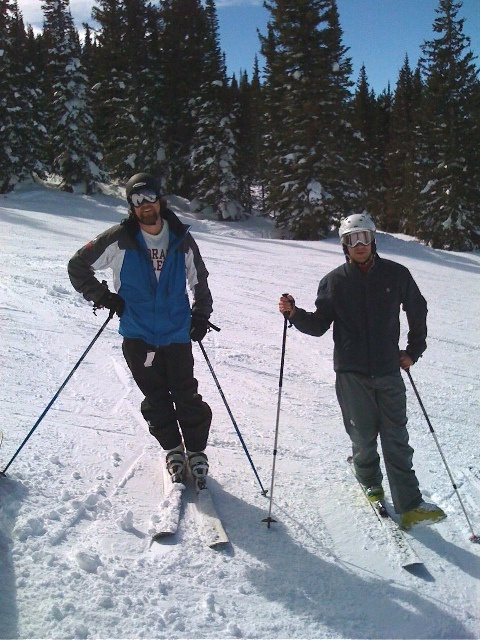Describe the objects in this image and their specific colors. I can see people in gray, black, lightgray, and darkgray tones, people in gray, black, navy, and lavender tones, and skis in gray, lightgray, and darkgray tones in this image. 